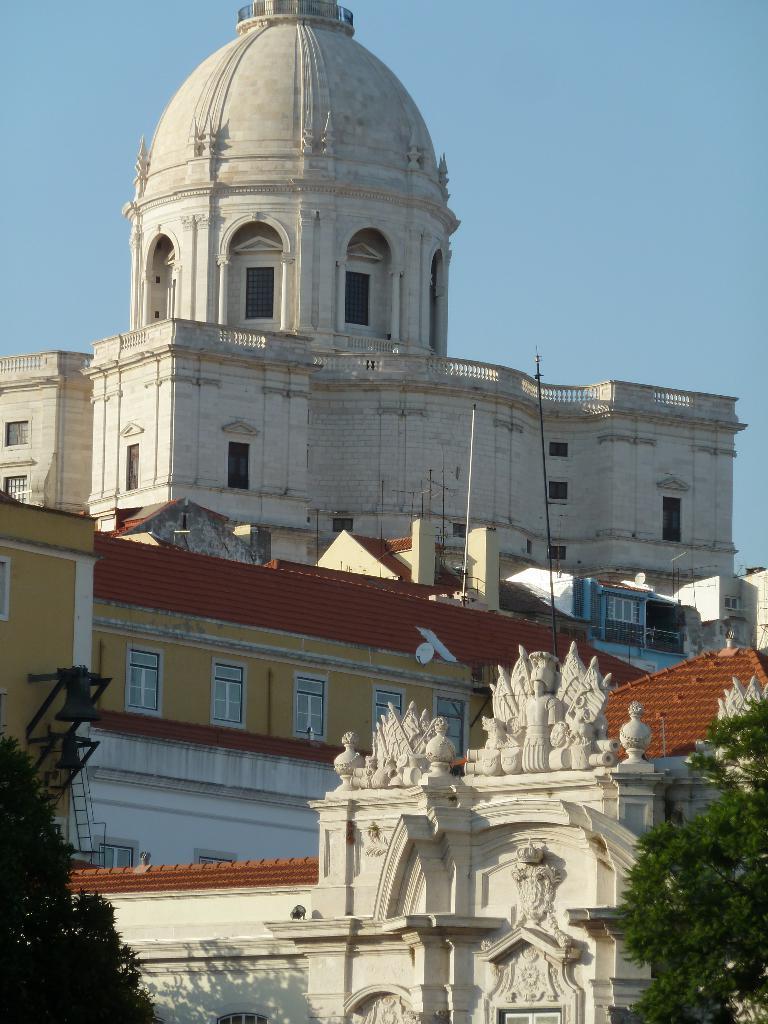How would you summarize this image in a sentence or two? In this picture we can see buildings, at the right bottom and left bottom there are trees, we can see the sky at the top of the picture. 